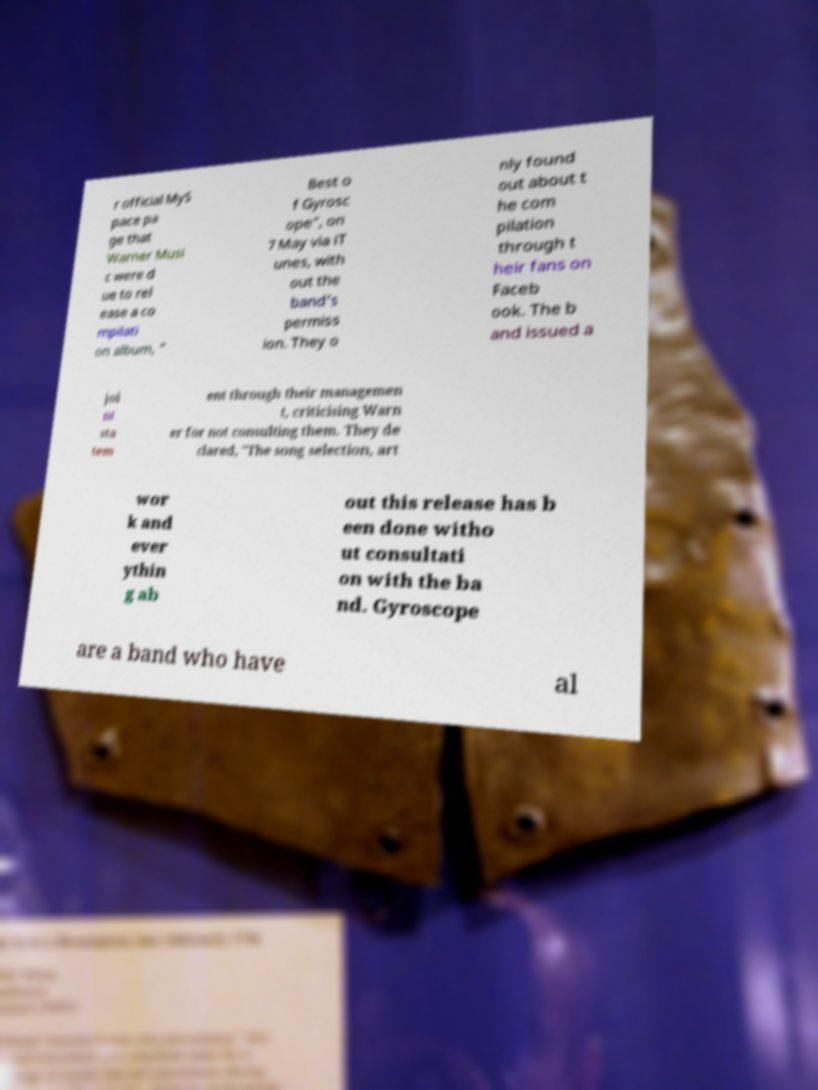Can you read and provide the text displayed in the image?This photo seems to have some interesting text. Can you extract and type it out for me? r official MyS pace pa ge that Warner Musi c were d ue to rel ease a co mpilati on album, " Best o f Gyrosc ope", on 7 May via iT unes, with out the band's permiss ion. They o nly found out about t he com pilation through t heir fans on Faceb ook. The b and issued a joi nt sta tem ent through their managemen t, criticising Warn er for not consulting them. They de clared, "The song selection, art wor k and ever ythin g ab out this release has b een done witho ut consultati on with the ba nd. Gyroscope are a band who have al 